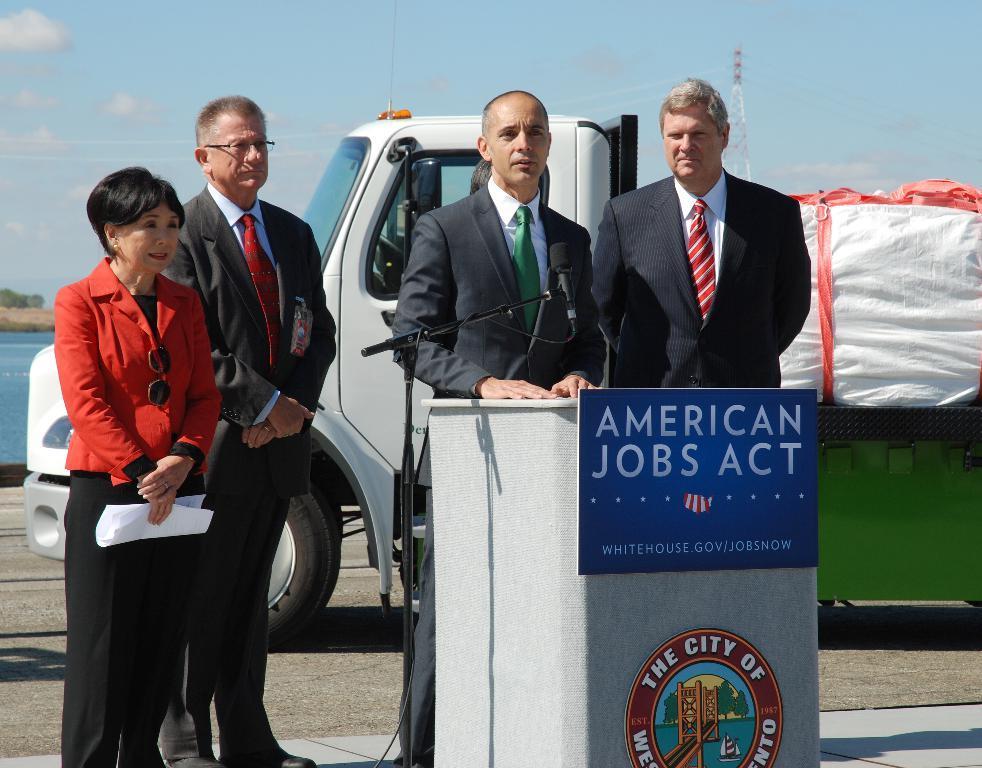Please provide a concise description of this image. In the picture I can see people standing on the ground. I can also see a podium, and microphone and a vehicle on the ground. In the background I can see the sky, water, a tower and some other objects. 